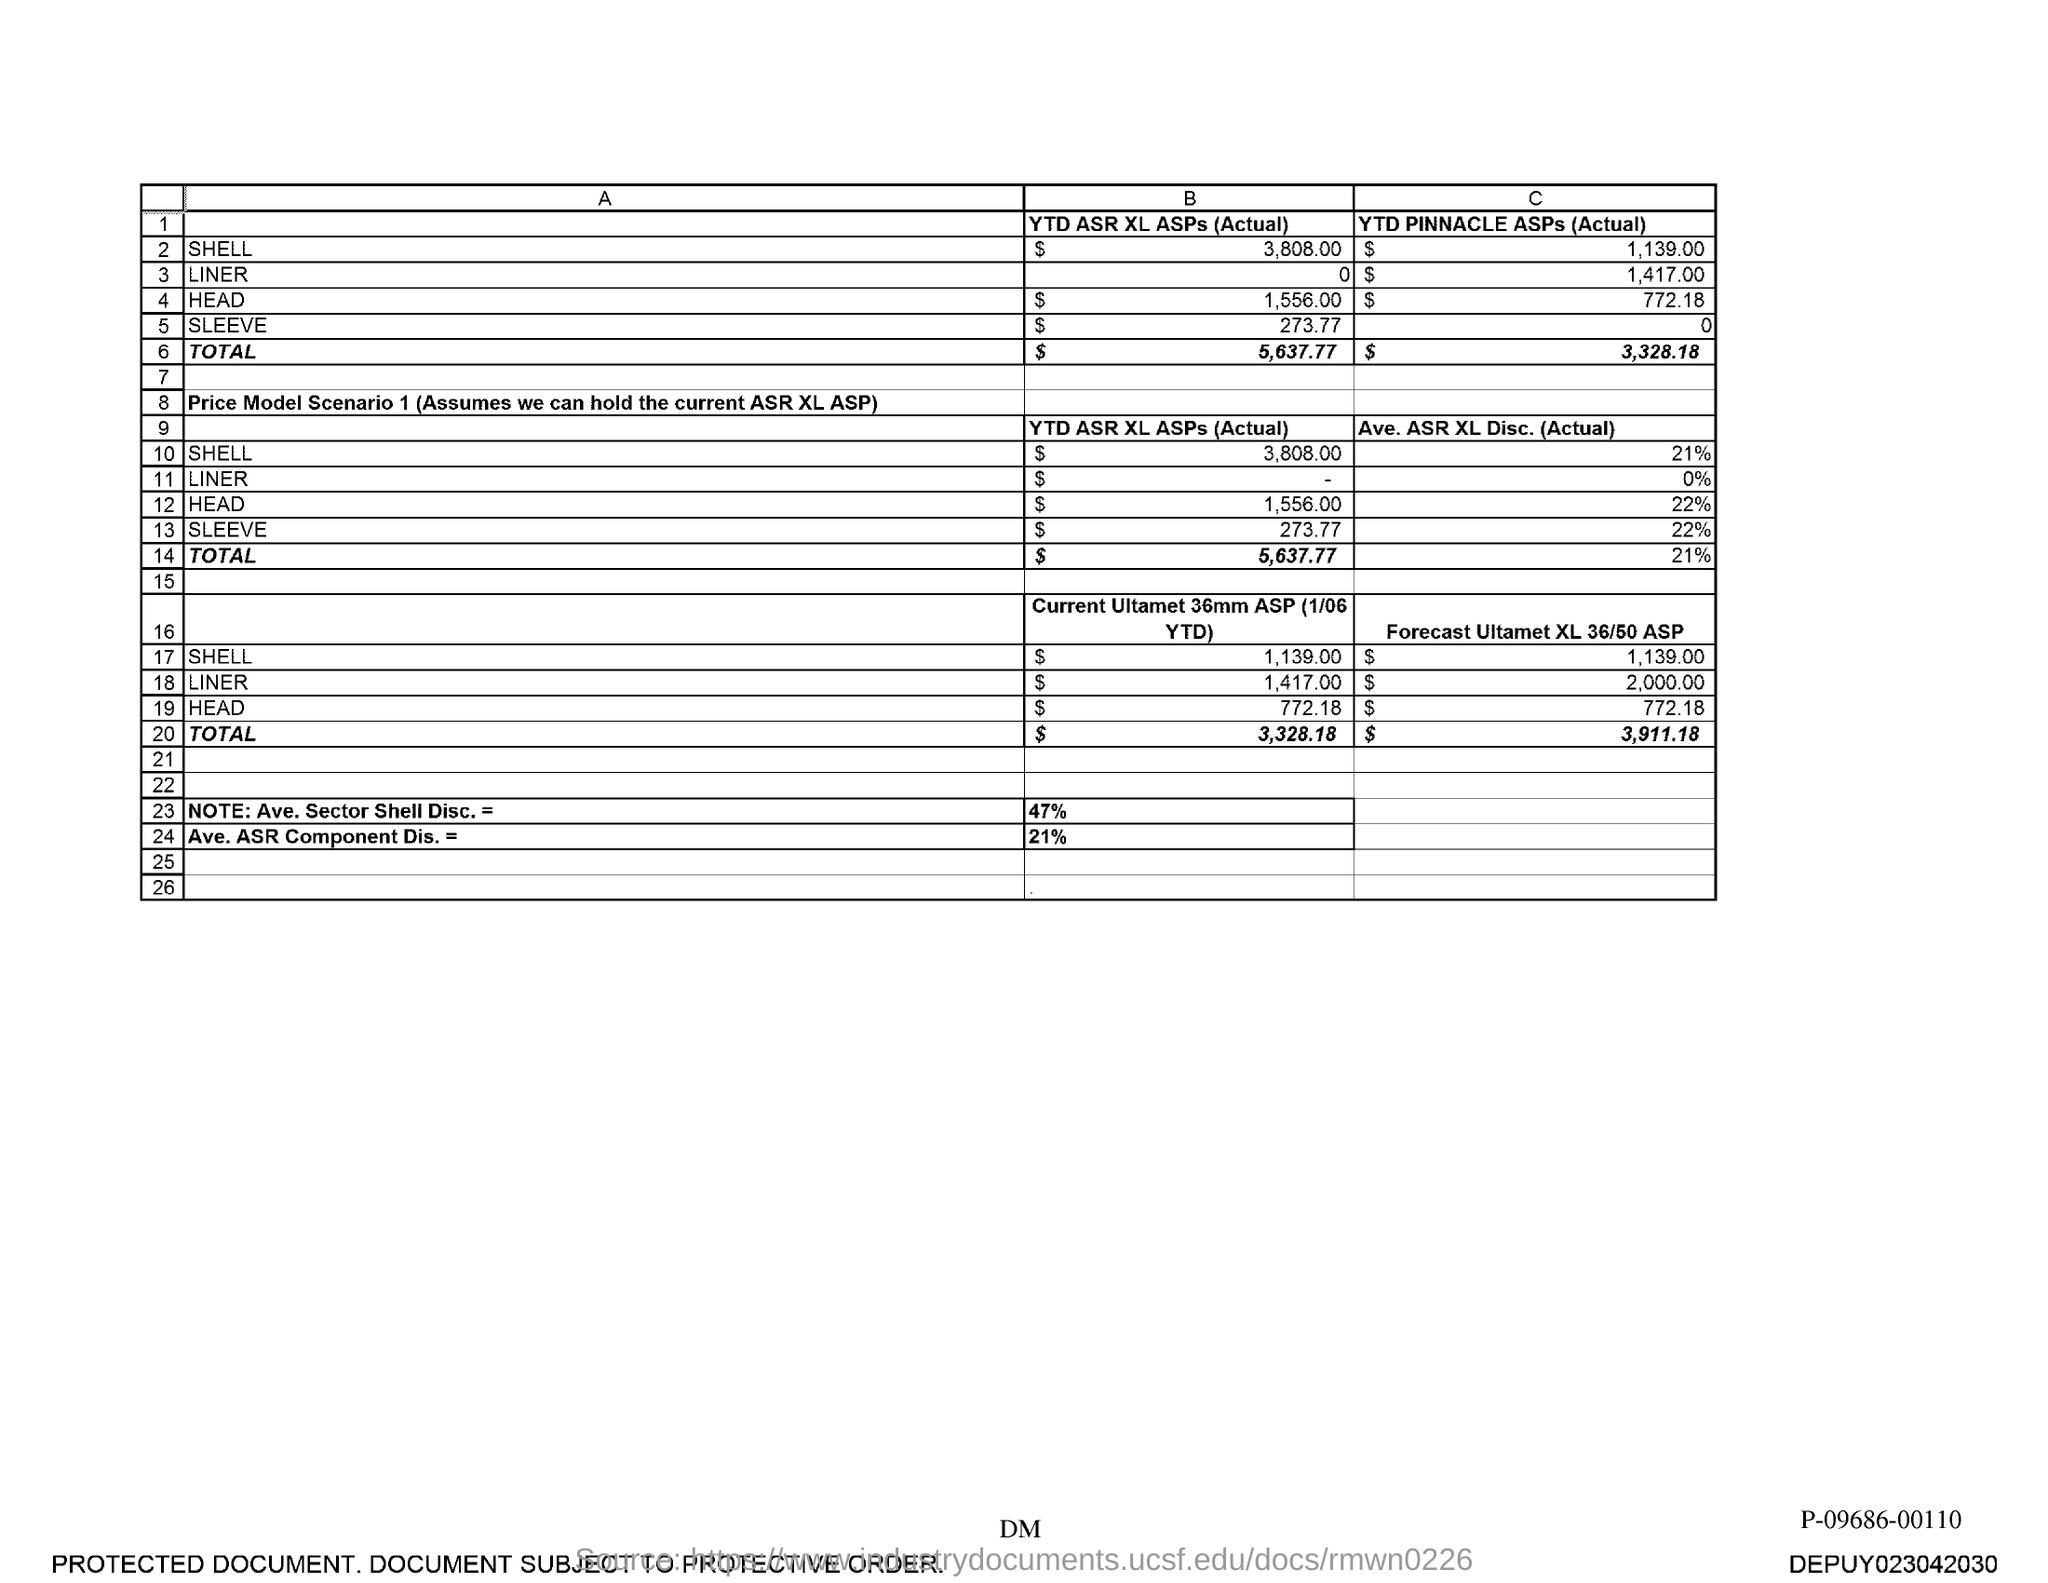What is the YTD Pinnacle ASPs (Actual) for Shell?
Offer a terse response. $ 1,139.00. What is the YTD Pinnacle ASPs (Actual) for Liner?
Offer a terse response. $1,417.00. What is the YTD Pinnacle ASPs (Actual) for Head?
Offer a terse response. $772.18. What is the YTD Pinnacle ASPs (Actual) for Sleeve?
Make the answer very short. 0. What is the Total YTD Pinnacle ASPs (Actual)?
Ensure brevity in your answer.  $ 3,328.18. What is the Ave. ASR XL Disc. (Actual) for Shell?
Your answer should be compact. 21%. What is the Ave. ASR XL Disc. (Actual) for Liner?
Provide a short and direct response. 0%. What is the Ave. ASR XL Disc. (Actual) for Head?
Offer a terse response. 22%. What is the Ave. ASR XL Disc. (Actual) for Sleeve?
Provide a short and direct response. 22%. What is the Total Ave. ASR XL Disc. (Actual)?
Offer a terse response. 21%. 